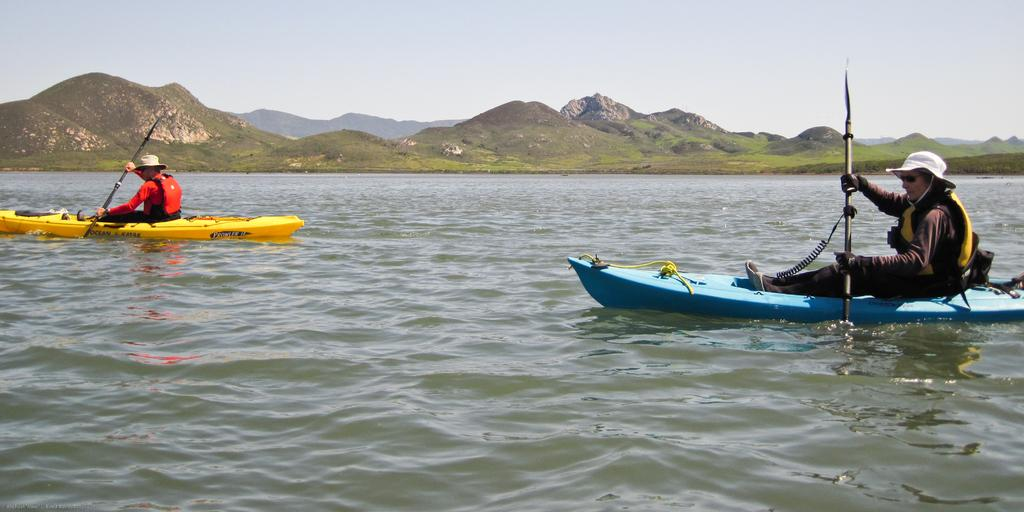What activity are the two people in the image engaged in? The two people in the image are kayaking. Where is the kayaking taking place? The kayaking is happening on the water. What can be seen in the background of the image? There are mountains and the sky visible in the background of the image. What type of cream can be seen on the monkey's fur in the image? There is no monkey or cream present in the image; it features two people kayaking on the water with mountains and the sky in the background. 